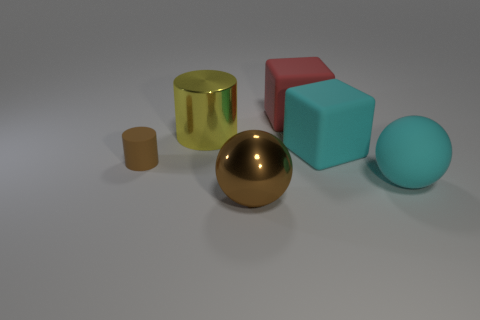Is there any other thing that is the same size as the matte cylinder?
Your answer should be very brief. No. What number of other objects are the same material as the brown ball?
Your answer should be very brief. 1. Is the number of rubber objects that are in front of the large yellow object greater than the number of rubber spheres on the left side of the small brown object?
Offer a terse response. Yes. There is a cyan object in front of the brown matte cylinder; what material is it?
Your response must be concise. Rubber. Does the red thing have the same shape as the small brown matte object?
Your answer should be very brief. No. Is there anything else of the same color as the small object?
Provide a short and direct response. Yes. There is another large object that is the same shape as the large red object; what is its color?
Ensure brevity in your answer.  Cyan. Is the number of things that are to the left of the large red matte block greater than the number of large rubber cubes?
Provide a short and direct response. Yes. There is a metallic thing that is behind the brown cylinder; what is its color?
Your answer should be very brief. Yellow. Is the brown rubber cylinder the same size as the yellow cylinder?
Ensure brevity in your answer.  No. 